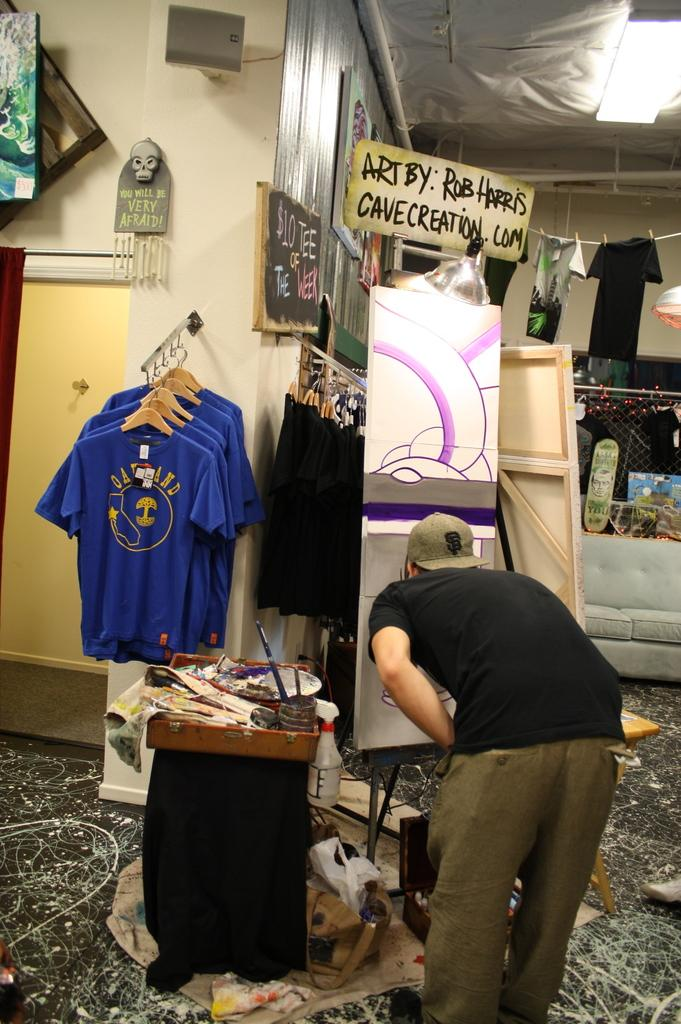<image>
Describe the image concisely. An artist is working under a sign that says Art By Rob Harris. 